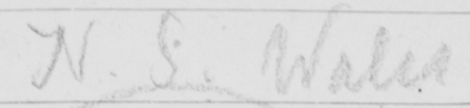What does this handwritten line say? N . S . Wales 